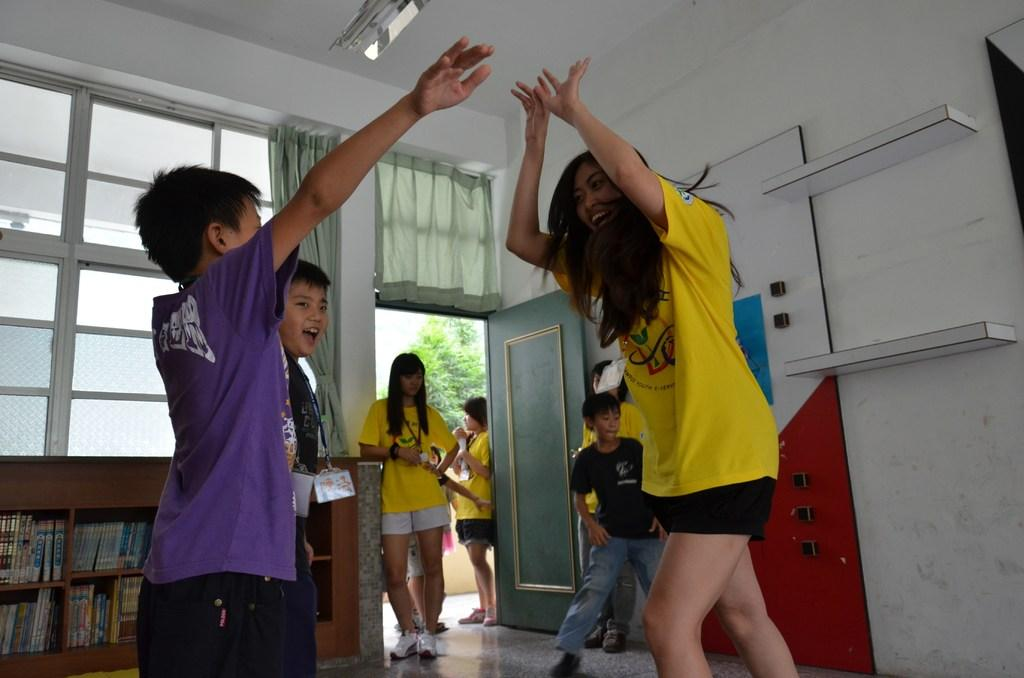How many people are present in the image? There are people in the image, but the exact number is not specified. What are some of the people doing in the image? Some of the people are playing in the image. What can be found on the wooden shelf in the image? There is a wooden shelf with books in the image. What architectural features are present on the wall in the image? The wall has a door and windows in the image. What type of window treatment is associated with the windows? There are curtains associated with the windows in the image. What type of flock can be seen flying outside the window in the image? There is no flock of birds or any other animals visible outside the window in the image. Is there a birthday celebration happening in the image? There is no indication of a birthday celebration in the image. 